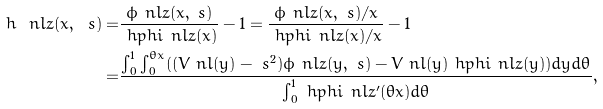Convert formula to latex. <formula><loc_0><loc_0><loc_500><loc_500>h _ { \ } n l z ( x , \ s ) = & \frac { \phi _ { \ } n l z ( x , \ s ) } { \ h p h i _ { \ } n l z ( x ) } - 1 = \frac { \phi _ { \ } n l z ( x , \ s ) / x } { \ h p h i _ { \ } n l z ( x ) / x } - 1 \\ = & \frac { \int _ { 0 } ^ { 1 } \int _ { 0 } ^ { \theta x } ( ( V _ { \ } n l ( y ) - \ s ^ { 2 } ) \phi _ { \ } n l z ( y , \ s ) - V _ { \ } n l ( y ) \ h p h i _ { \ } n l z ( y ) ) d y d \theta } { \int _ { 0 } ^ { 1 } \ h p h i _ { \ } n l z ^ { \prime } ( \theta x ) d \theta } ,</formula> 